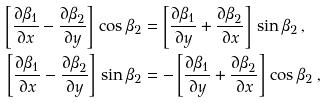<formula> <loc_0><loc_0><loc_500><loc_500>\left [ \frac { \partial \beta _ { 1 } } { \partial x } - \frac { \partial \beta _ { 2 } } { \partial y } \right ] \, \cos \beta _ { 2 } & = \left [ \frac { \partial \beta _ { 1 } } { \partial y } + \frac { \partial \beta _ { 2 } } { \partial x } \right ] \, \sin \beta _ { 2 } \, , \\ \left [ \frac { \partial \beta _ { 1 } } { \partial x } - \frac { \partial \beta _ { 2 } } { \partial y } \right ] \, \sin \beta _ { 2 } & = - \left [ \frac { \partial \beta _ { 1 } } { \partial y } + \frac { \partial \beta _ { 2 } } { \partial x } \right ] \, \cos \beta _ { 2 } \, ,</formula> 